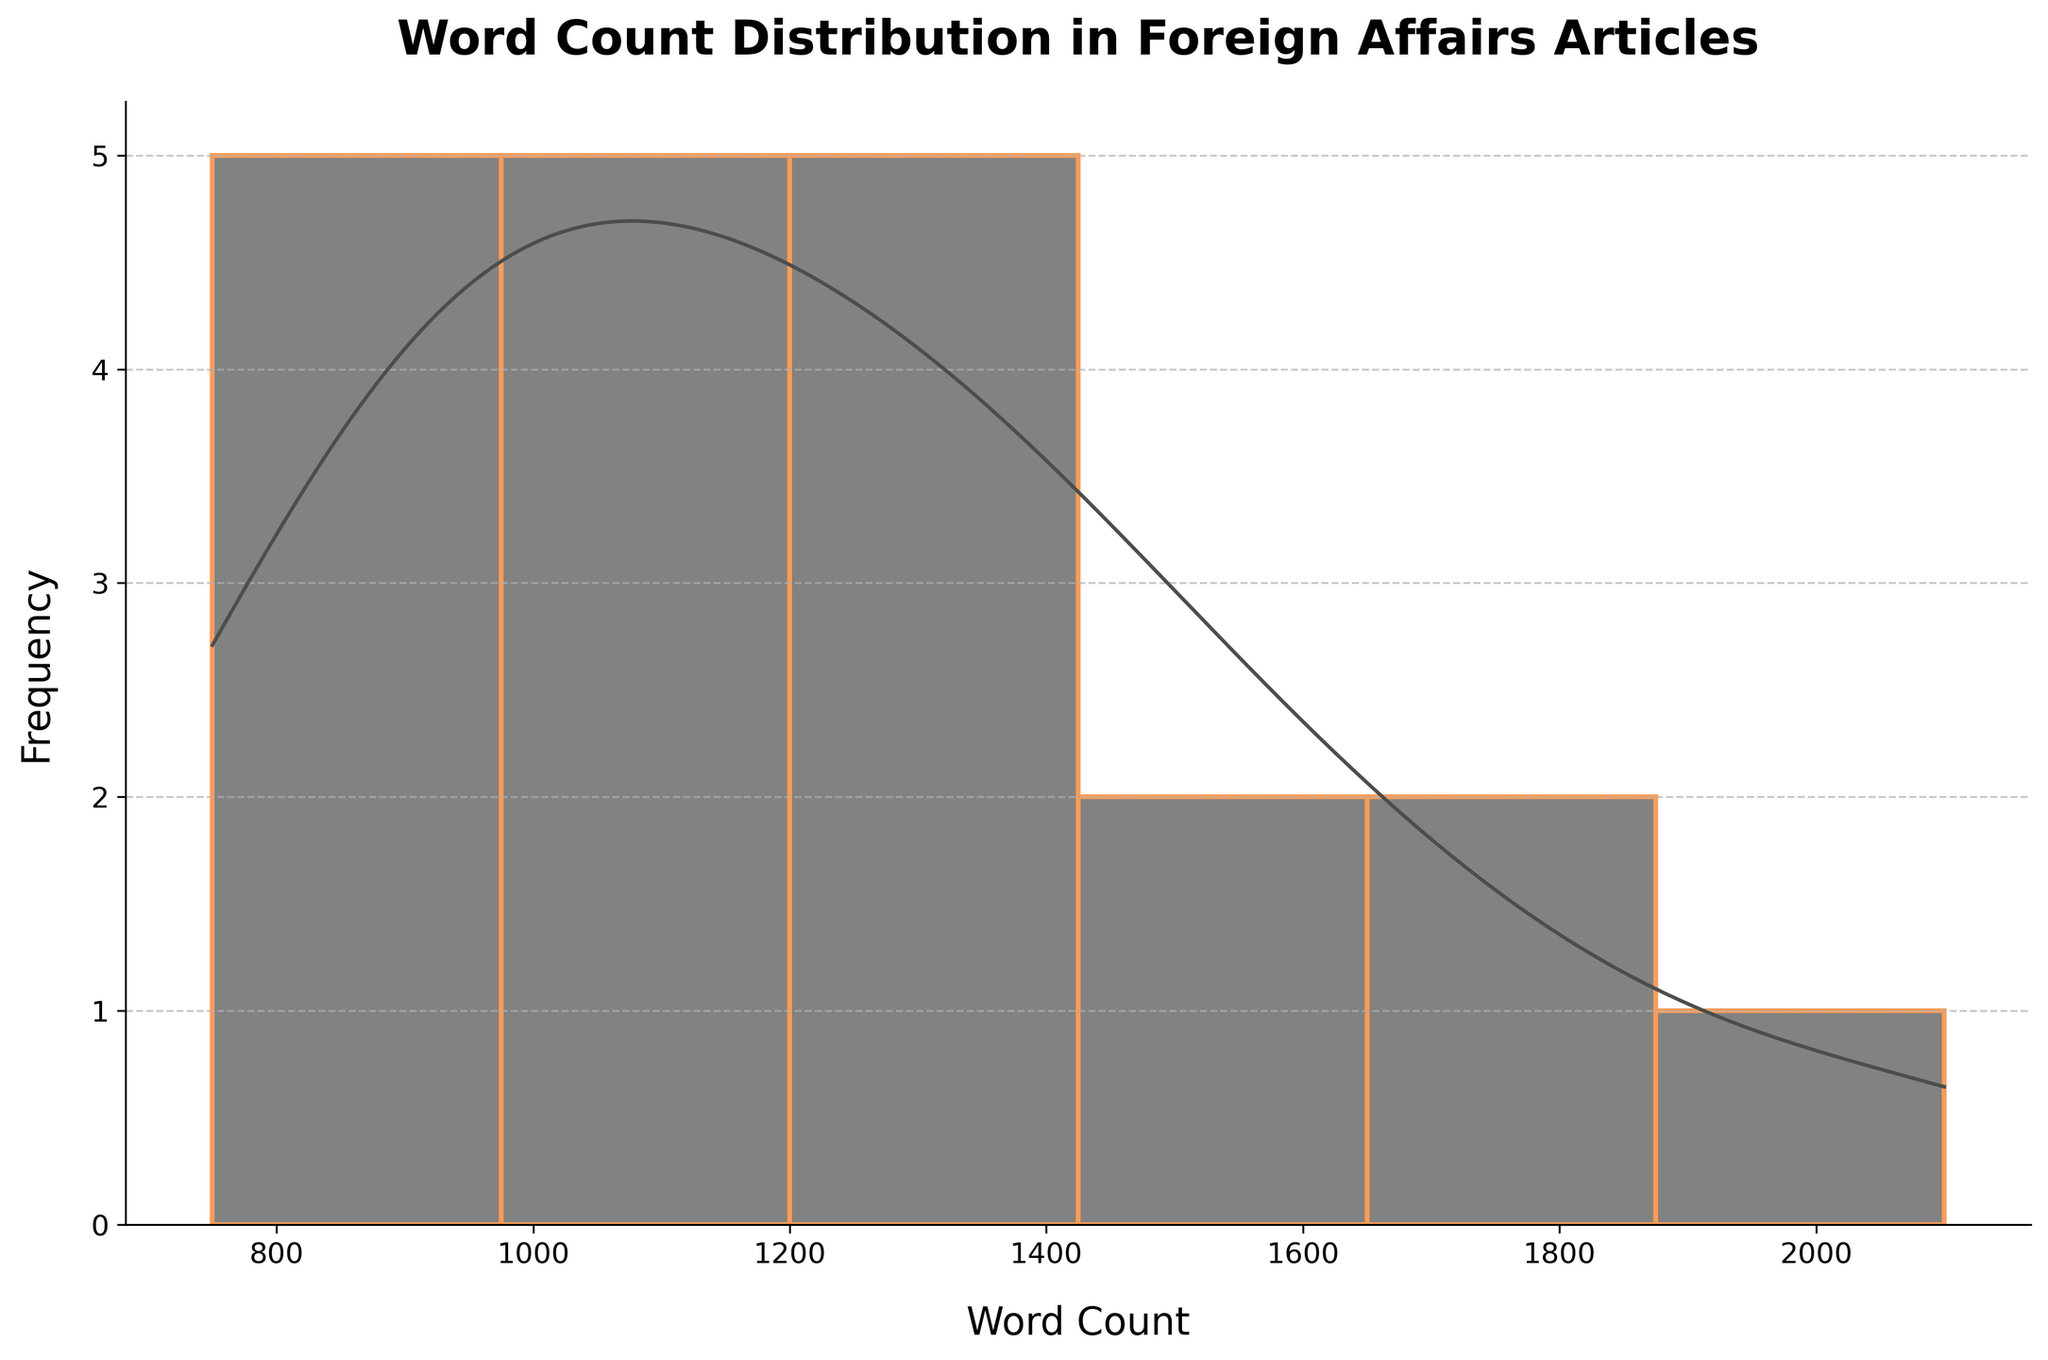What is the title of the figure? The title is usually placed at the center and the top of the plot. By looking at the figure's top section, you can read the title.
Answer: Word Count Distribution in Foreign Affairs Articles What is the range of the x-axis? The x-axis represents the word count. By checking the start and end points of the x-axis, you can determine its range.
Answer: 700 to 2200 Which word count range appears most frequently? You can determine this by identifying the highest bar or peak in the histogram part of the plot.
Answer: Around 1200-1400 words Does the figure include a KDE (density curve)? If so, what color is it? Check if there's a smooth line overlay over the histogram bars. Observe the color of this line to answer the question.
Answer: Yes, gray Which news platform has the highest word count, and what is that count? The highest word count would be the rightmost data point on the x-axis or the highest peak on the KDE curve. Calculate by checking the data points against this peak.
Answer: Foreign Affairs, 2100 words What's the minimum word count, and which news platforms have this word count? Identify the smallest data point at the start of the x-axis or the KDE curve and match it with the dataset to find the platforms.
Answer: Reuters, 750 words Between 1000 and 1300 words, which platforms fall in this range, and approximately how many articles are there? Identify the bars falling within the 1000-1300 range in the histogram and count the tally. Then associate it with the platforms from the dataset.
Answer: The Guardian, BBC News, Politico, Financial Times, NPR, Bloomberg; 7 articles What is the median word count of foreign affairs articles? To find the median, sort the dataset in ascending order of the word count and find the middle value. If the number of data points is odd, the middle value is the median. If even, the average of the two middle values is the median.
Answer: 1150 words How does the frequency of articles with word counts above 1500 compare to those below? Count the number of histogram bars and their heights for word counts above 1500 and compare them with those below 1500.
Answer: More articles are below 1500 words Is there a significant difference between the word counts of articles by The Atlantic and NPR? Check both platforms' word counts from the dataset. Subtract the lower count from the higher count to determine the difference.
Answer: Yes, 850 words (The Atlantic: 1800, NPR: 950) 